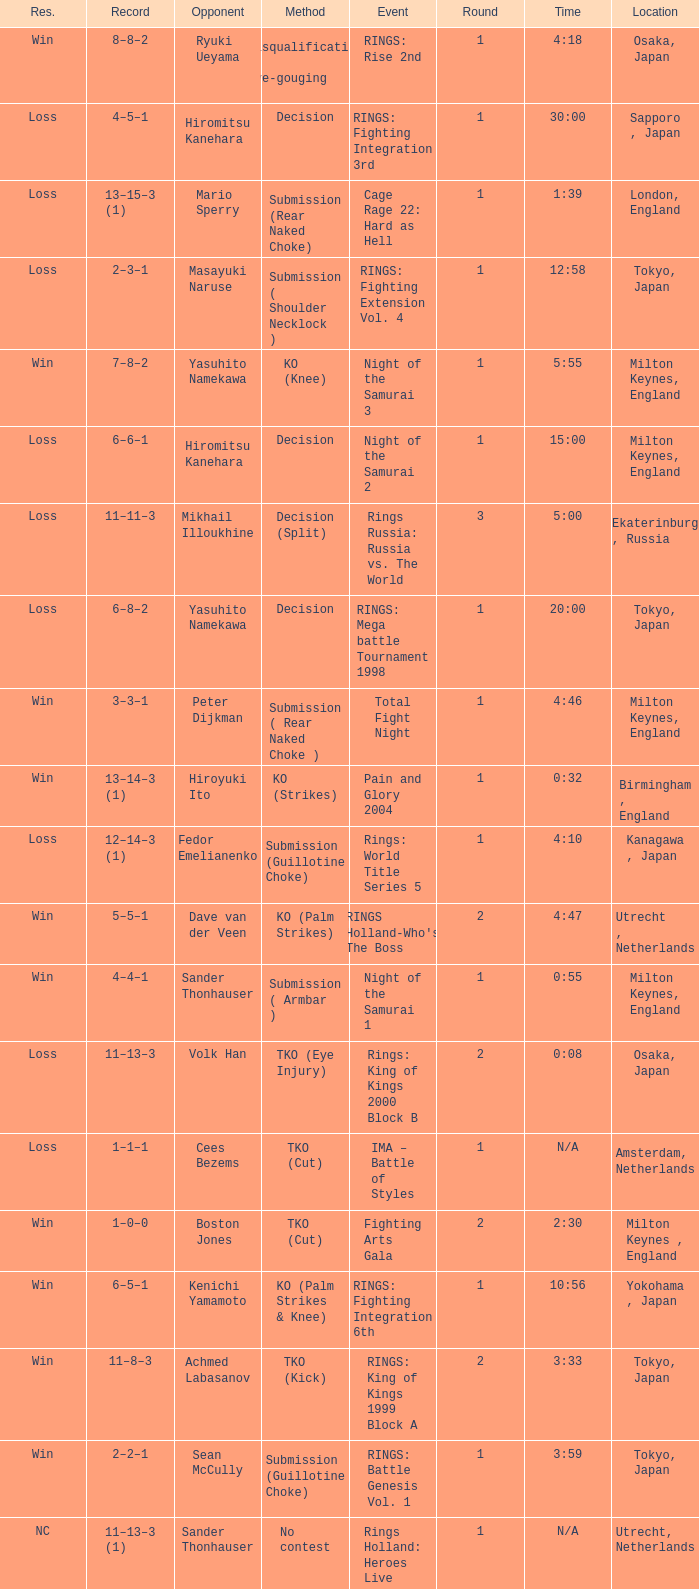Which event had an opponent of Yasuhito Namekawa with a decision method? RINGS: Mega battle Tournament 1998. 